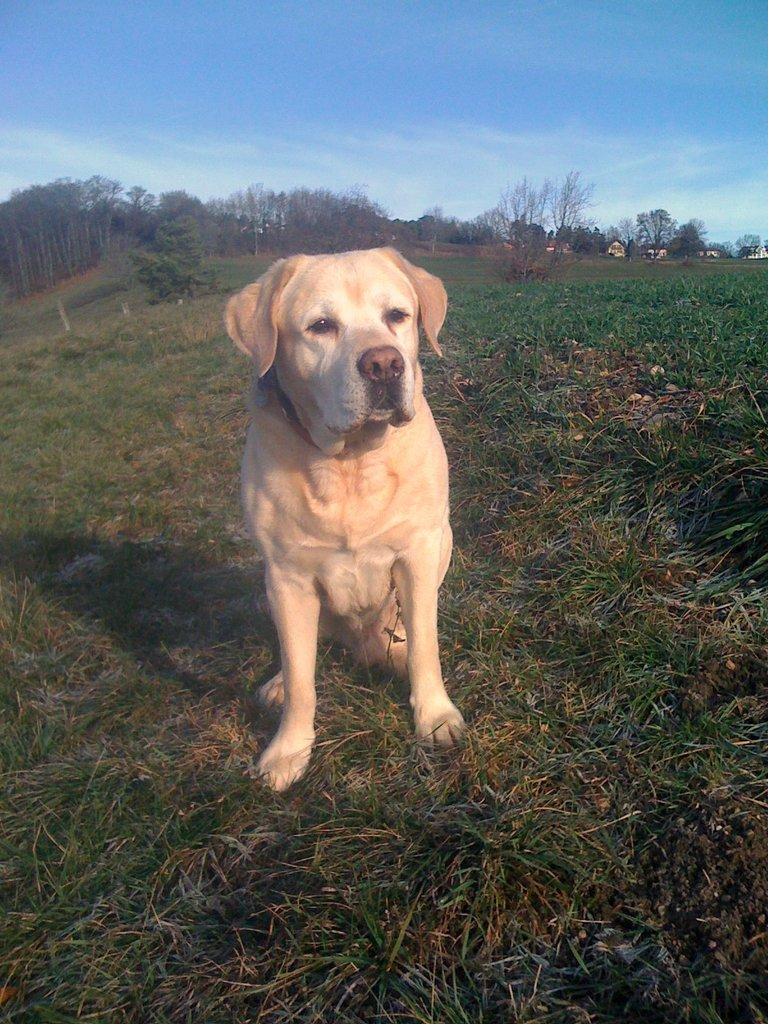What animal can be seen in the image? There is a dog in the image. What is the dog doing in the image? The dog is sitting on the ground. What type of surface is the dog sitting on? The ground is covered with grass. What can be seen in the distance behind the dog? There are trees visible in the background. How would you describe the weather based on the image? The sky is clear, suggesting good weather. What type of fowl is sitting next to the dog in the image? There is no fowl present in the image; it only features a dog sitting on the grass. 